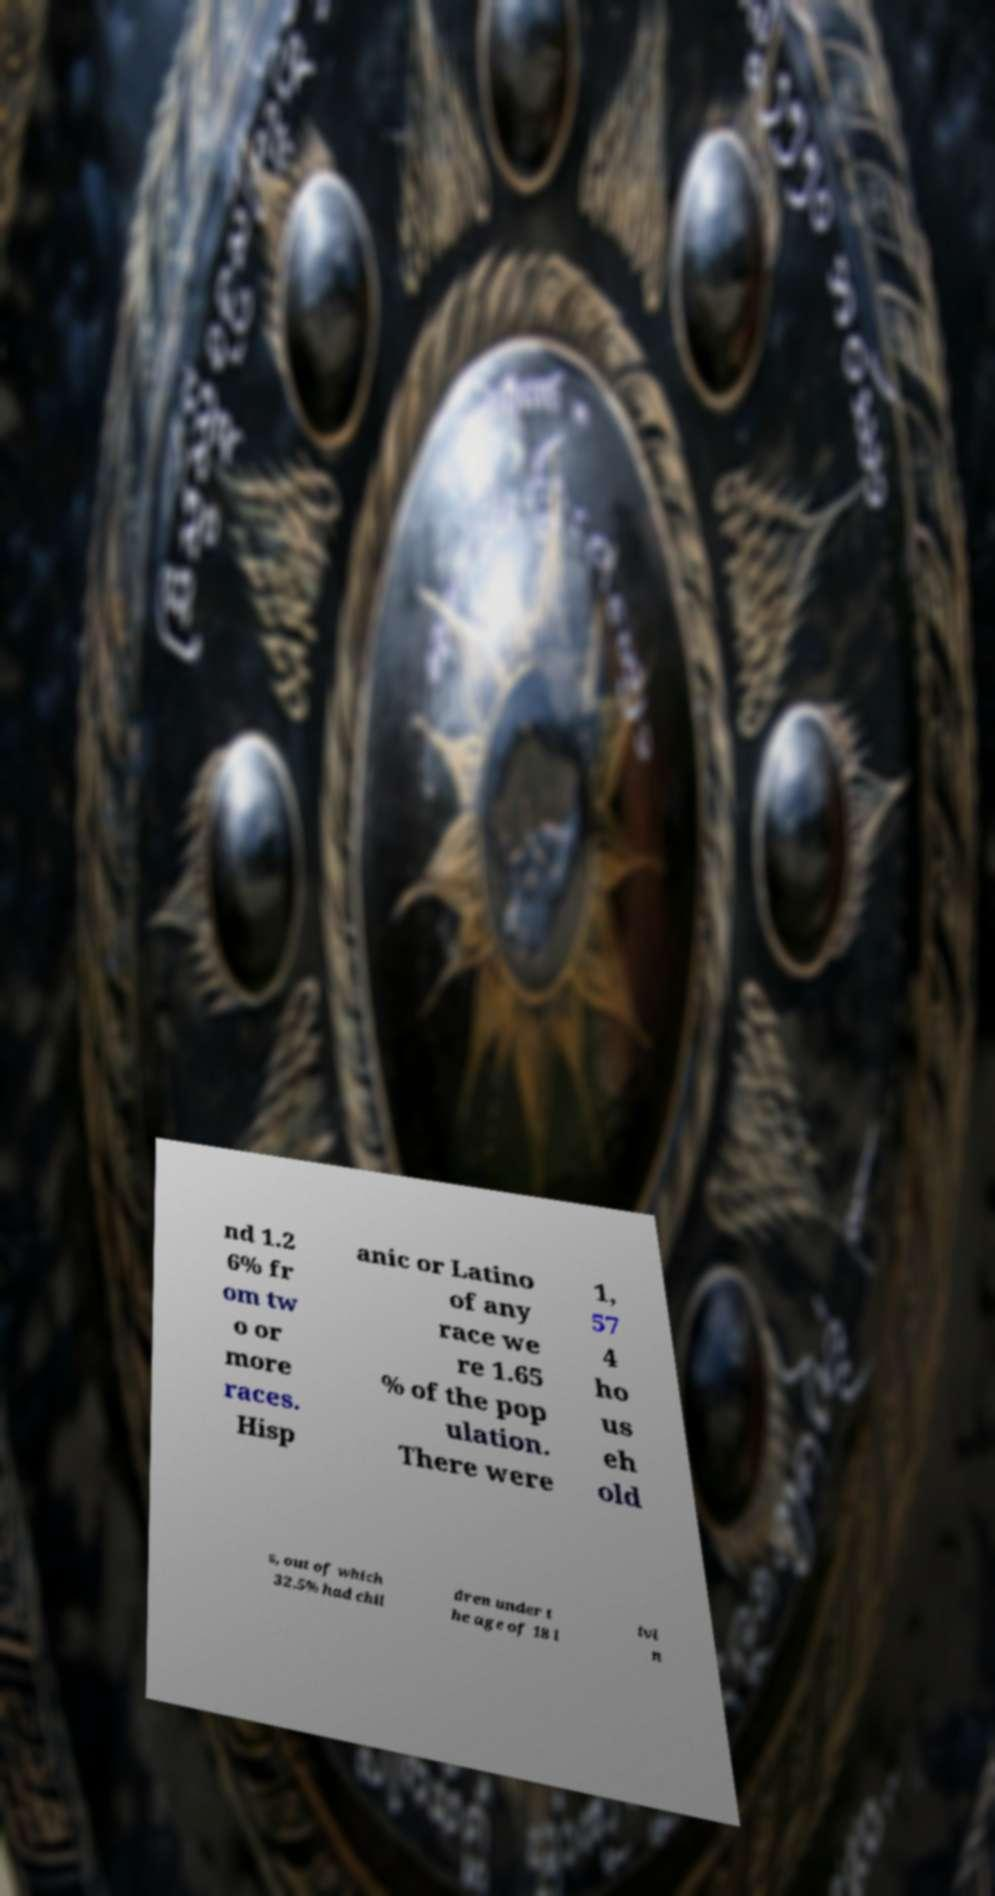Can you read and provide the text displayed in the image?This photo seems to have some interesting text. Can you extract and type it out for me? nd 1.2 6% fr om tw o or more races. Hisp anic or Latino of any race we re 1.65 % of the pop ulation. There were 1, 57 4 ho us eh old s, out of which 32.5% had chil dren under t he age of 18 l ivi n 